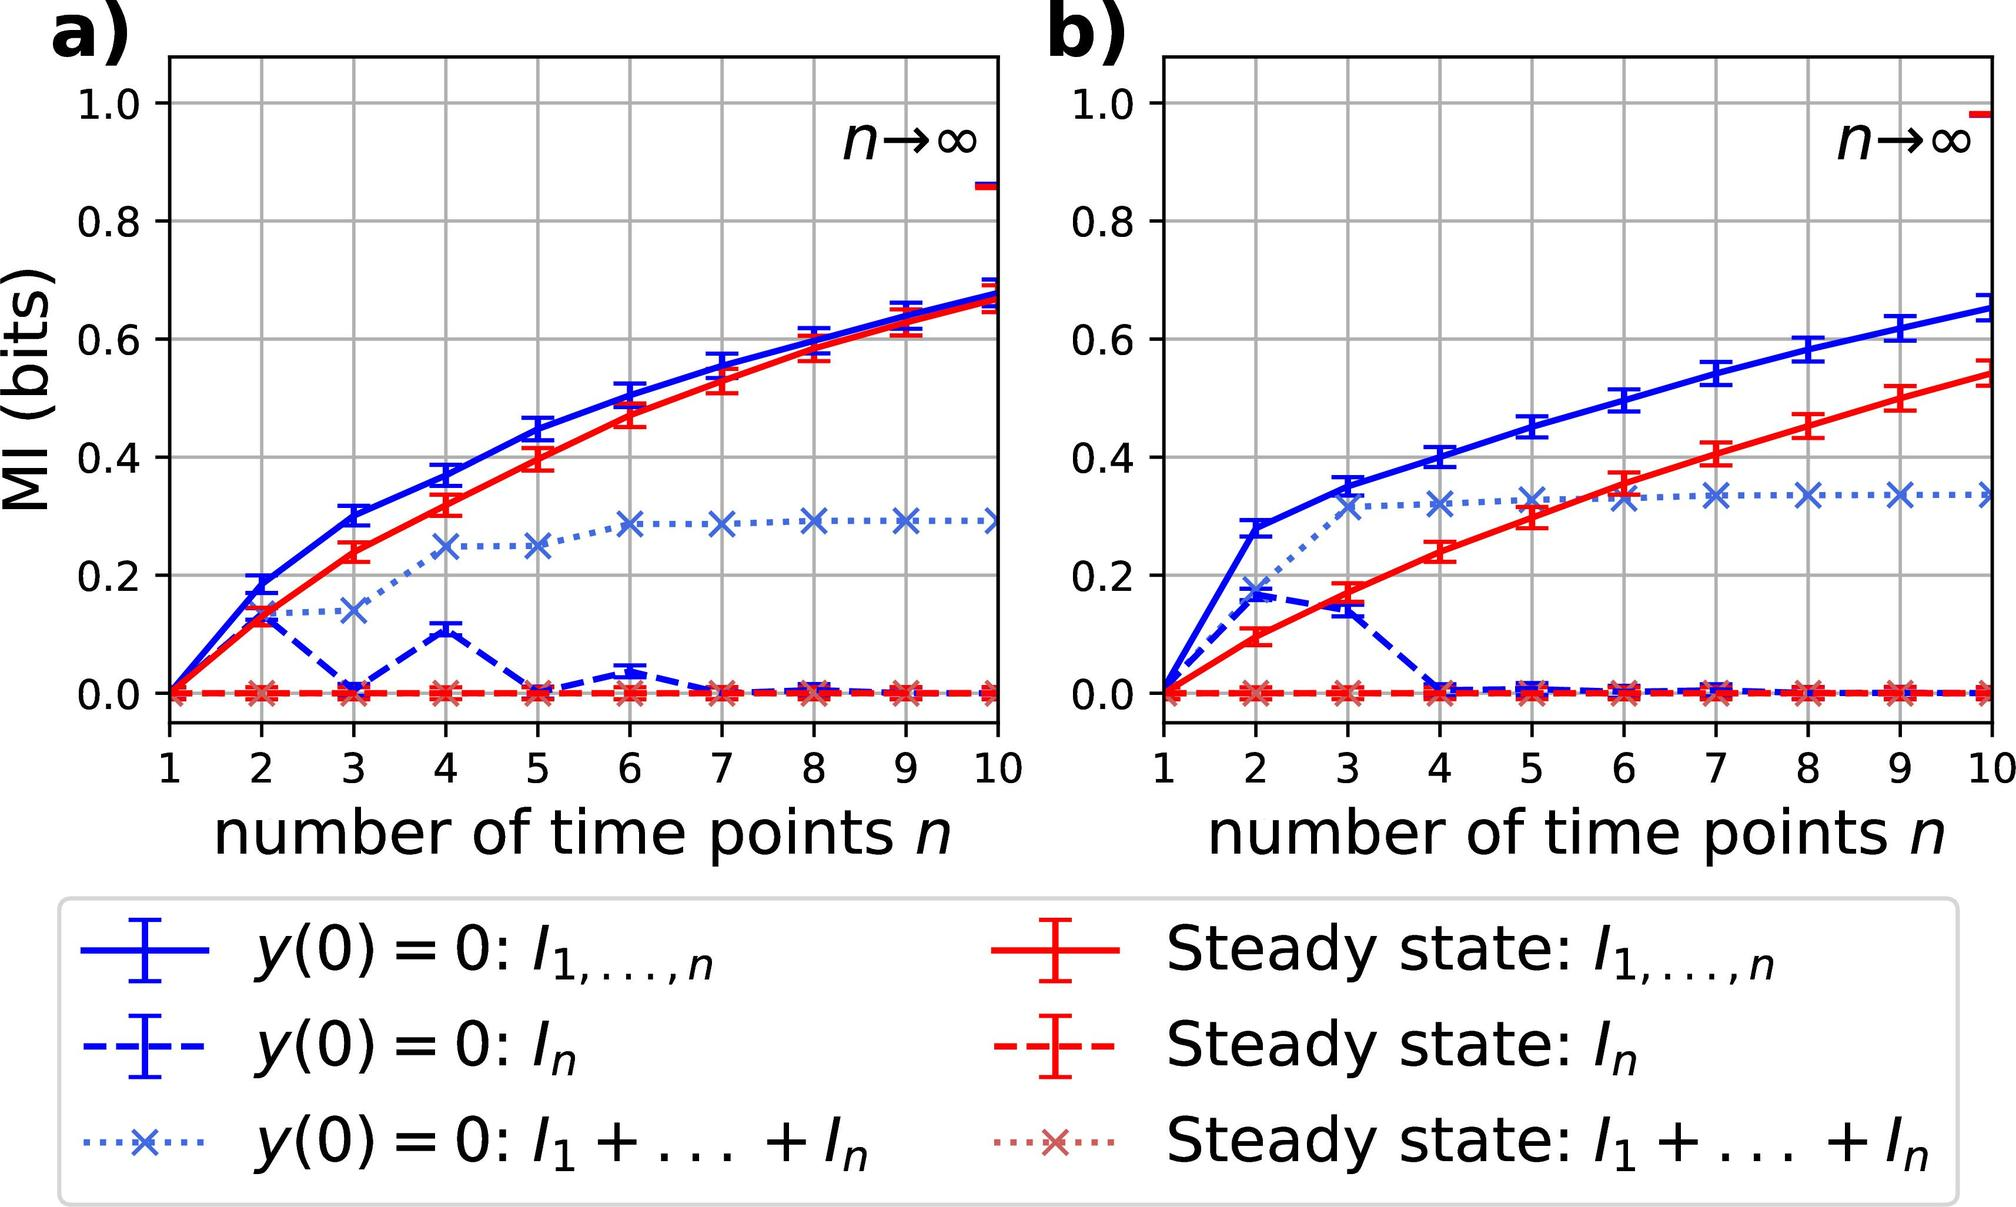How would you interpret the difference in patterns between figure a) and figure b)? Figure a) and figure b) both show curves that represent how MI scales with an increasing number of time points, but they do so under different conditions or states. The patterns in figure a) depict MI development under initial conditions, whereas figure b) shows MI in a steady state, reflecting the system's behavior after it has settled into equilibrium. The difference in the patterns suggests that the dynamics of the system vary significantly from the initial transient phase to the steady state, and studying these can provide insights into the properties and response characteristics of the system over time. 